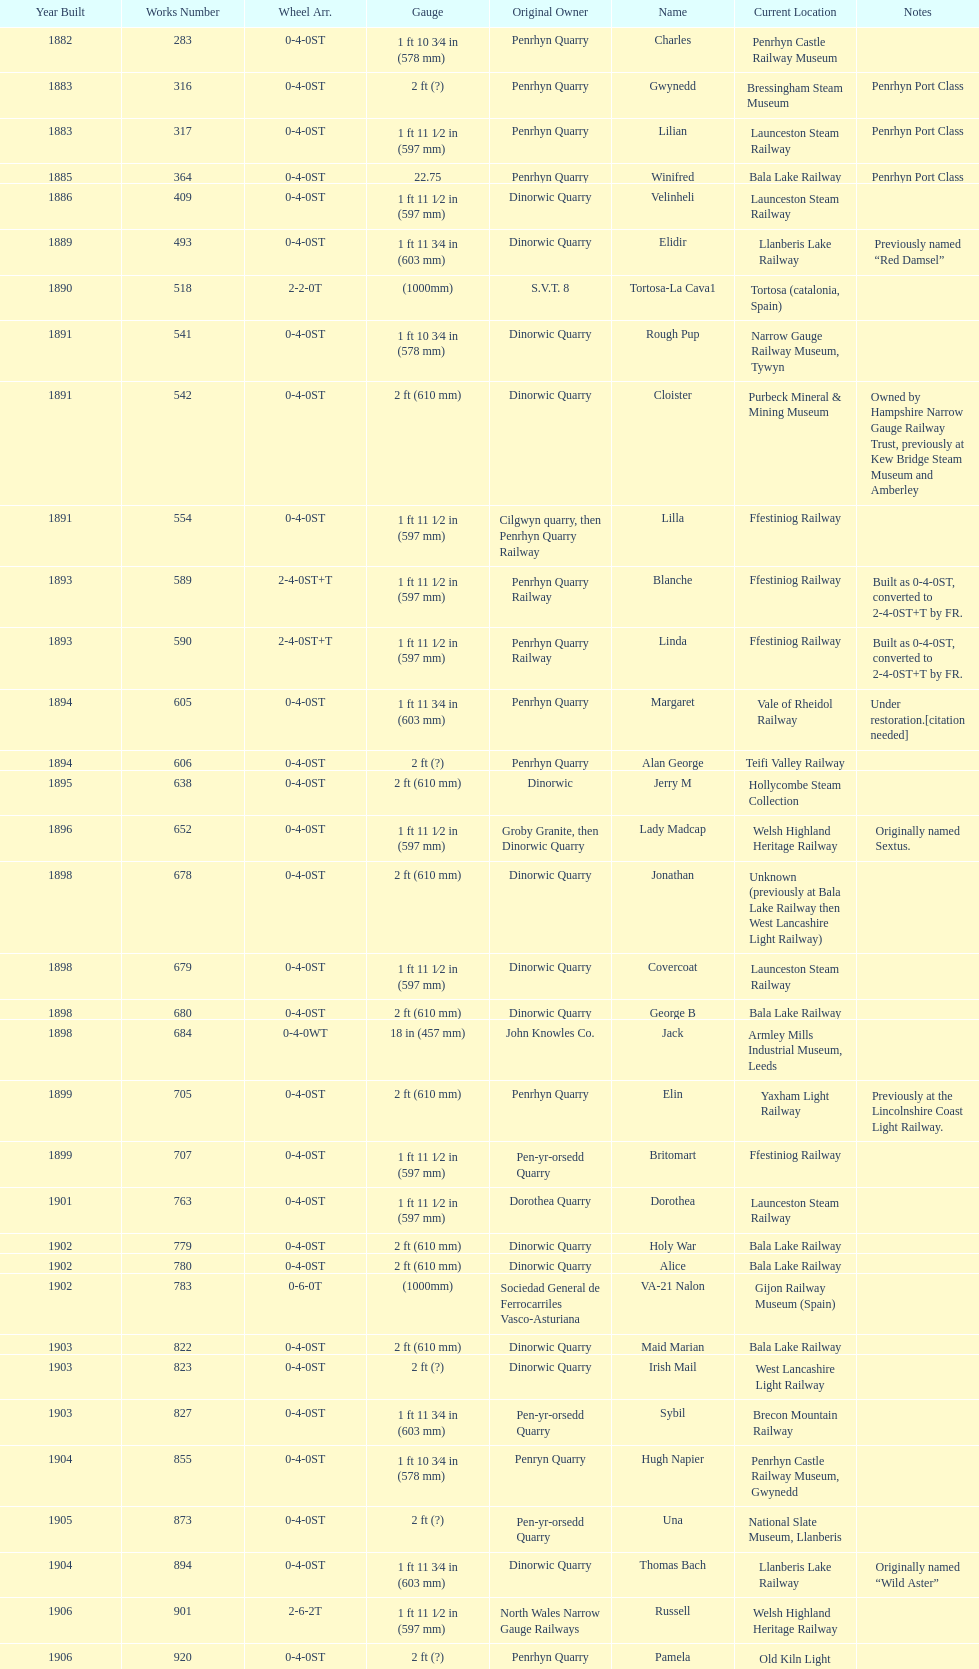Can you parse all the data within this table? {'header': ['Year Built', 'Works Number', 'Wheel Arr.', 'Gauge', 'Original Owner', 'Name', 'Current Location', 'Notes'], 'rows': [['1882', '283', '0-4-0ST', '1\xa0ft 10\xa03⁄4\xa0in (578\xa0mm)', 'Penrhyn Quarry', 'Charles', 'Penrhyn Castle Railway Museum', ''], ['1883', '316', '0-4-0ST', '2\xa0ft (?)', 'Penrhyn Quarry', 'Gwynedd', 'Bressingham Steam Museum', 'Penrhyn Port Class'], ['1883', '317', '0-4-0ST', '1\xa0ft 11\xa01⁄2\xa0in (597\xa0mm)', 'Penrhyn Quarry', 'Lilian', 'Launceston Steam Railway', 'Penrhyn Port Class'], ['1885', '364', '0-4-0ST', '22.75', 'Penrhyn Quarry', 'Winifred', 'Bala Lake Railway', 'Penrhyn Port Class'], ['1886', '409', '0-4-0ST', '1\xa0ft 11\xa01⁄2\xa0in (597\xa0mm)', 'Dinorwic Quarry', 'Velinheli', 'Launceston Steam Railway', ''], ['1889', '493', '0-4-0ST', '1\xa0ft 11\xa03⁄4\xa0in (603\xa0mm)', 'Dinorwic Quarry', 'Elidir', 'Llanberis Lake Railway', 'Previously named “Red Damsel”'], ['1890', '518', '2-2-0T', '(1000mm)', 'S.V.T. 8', 'Tortosa-La Cava1', 'Tortosa (catalonia, Spain)', ''], ['1891', '541', '0-4-0ST', '1\xa0ft 10\xa03⁄4\xa0in (578\xa0mm)', 'Dinorwic Quarry', 'Rough Pup', 'Narrow Gauge Railway Museum, Tywyn', ''], ['1891', '542', '0-4-0ST', '2\xa0ft (610\xa0mm)', 'Dinorwic Quarry', 'Cloister', 'Purbeck Mineral & Mining Museum', 'Owned by Hampshire Narrow Gauge Railway Trust, previously at Kew Bridge Steam Museum and Amberley'], ['1891', '554', '0-4-0ST', '1\xa0ft 11\xa01⁄2\xa0in (597\xa0mm)', 'Cilgwyn quarry, then Penrhyn Quarry Railway', 'Lilla', 'Ffestiniog Railway', ''], ['1893', '589', '2-4-0ST+T', '1\xa0ft 11\xa01⁄2\xa0in (597\xa0mm)', 'Penrhyn Quarry Railway', 'Blanche', 'Ffestiniog Railway', 'Built as 0-4-0ST, converted to 2-4-0ST+T by FR.'], ['1893', '590', '2-4-0ST+T', '1\xa0ft 11\xa01⁄2\xa0in (597\xa0mm)', 'Penrhyn Quarry Railway', 'Linda', 'Ffestiniog Railway', 'Built as 0-4-0ST, converted to 2-4-0ST+T by FR.'], ['1894', '605', '0-4-0ST', '1\xa0ft 11\xa03⁄4\xa0in (603\xa0mm)', 'Penrhyn Quarry', 'Margaret', 'Vale of Rheidol Railway', 'Under restoration.[citation needed]'], ['1894', '606', '0-4-0ST', '2\xa0ft (?)', 'Penrhyn Quarry', 'Alan George', 'Teifi Valley Railway', ''], ['1895', '638', '0-4-0ST', '2\xa0ft (610\xa0mm)', 'Dinorwic', 'Jerry M', 'Hollycombe Steam Collection', ''], ['1896', '652', '0-4-0ST', '1\xa0ft 11\xa01⁄2\xa0in (597\xa0mm)', 'Groby Granite, then Dinorwic Quarry', 'Lady Madcap', 'Welsh Highland Heritage Railway', 'Originally named Sextus.'], ['1898', '678', '0-4-0ST', '2\xa0ft (610\xa0mm)', 'Dinorwic Quarry', 'Jonathan', 'Unknown (previously at Bala Lake Railway then West Lancashire Light Railway)', ''], ['1898', '679', '0-4-0ST', '1\xa0ft 11\xa01⁄2\xa0in (597\xa0mm)', 'Dinorwic Quarry', 'Covercoat', 'Launceston Steam Railway', ''], ['1898', '680', '0-4-0ST', '2\xa0ft (610\xa0mm)', 'Dinorwic Quarry', 'George B', 'Bala Lake Railway', ''], ['1898', '684', '0-4-0WT', '18\xa0in (457\xa0mm)', 'John Knowles Co.', 'Jack', 'Armley Mills Industrial Museum, Leeds', ''], ['1899', '705', '0-4-0ST', '2\xa0ft (610\xa0mm)', 'Penrhyn Quarry', 'Elin', 'Yaxham Light Railway', 'Previously at the Lincolnshire Coast Light Railway.'], ['1899', '707', '0-4-0ST', '1\xa0ft 11\xa01⁄2\xa0in (597\xa0mm)', 'Pen-yr-orsedd Quarry', 'Britomart', 'Ffestiniog Railway', ''], ['1901', '763', '0-4-0ST', '1\xa0ft 11\xa01⁄2\xa0in (597\xa0mm)', 'Dorothea Quarry', 'Dorothea', 'Launceston Steam Railway', ''], ['1902', '779', '0-4-0ST', '2\xa0ft (610\xa0mm)', 'Dinorwic Quarry', 'Holy War', 'Bala Lake Railway', ''], ['1902', '780', '0-4-0ST', '2\xa0ft (610\xa0mm)', 'Dinorwic Quarry', 'Alice', 'Bala Lake Railway', ''], ['1902', '783', '0-6-0T', '(1000mm)', 'Sociedad General de Ferrocarriles Vasco-Asturiana', 'VA-21 Nalon', 'Gijon Railway Museum (Spain)', ''], ['1903', '822', '0-4-0ST', '2\xa0ft (610\xa0mm)', 'Dinorwic Quarry', 'Maid Marian', 'Bala Lake Railway', ''], ['1903', '823', '0-4-0ST', '2\xa0ft (?)', 'Dinorwic Quarry', 'Irish Mail', 'West Lancashire Light Railway', ''], ['1903', '827', '0-4-0ST', '1\xa0ft 11\xa03⁄4\xa0in (603\xa0mm)', 'Pen-yr-orsedd Quarry', 'Sybil', 'Brecon Mountain Railway', ''], ['1904', '855', '0-4-0ST', '1\xa0ft 10\xa03⁄4\xa0in (578\xa0mm)', 'Penryn Quarry', 'Hugh Napier', 'Penrhyn Castle Railway Museum, Gwynedd', ''], ['1905', '873', '0-4-0ST', '2\xa0ft (?)', 'Pen-yr-orsedd Quarry', 'Una', 'National Slate Museum, Llanberis', ''], ['1904', '894', '0-4-0ST', '1\xa0ft 11\xa03⁄4\xa0in (603\xa0mm)', 'Dinorwic Quarry', 'Thomas Bach', 'Llanberis Lake Railway', 'Originally named “Wild Aster”'], ['1906', '901', '2-6-2T', '1\xa0ft 11\xa01⁄2\xa0in (597\xa0mm)', 'North Wales Narrow Gauge Railways', 'Russell', 'Welsh Highland Heritage Railway', ''], ['1906', '920', '0-4-0ST', '2\xa0ft (?)', 'Penrhyn Quarry', 'Pamela', 'Old Kiln Light Railway', ''], ['1909', '994', '0-4-0ST', '2\xa0ft (?)', 'Penrhyn Quarry', 'Bill Harvey', 'Bressingham Steam Museum', 'previously George Sholto'], ['1918', '1312', '4-6-0T', '1\xa0ft\xa011\xa01⁄2\xa0in (597\xa0mm)', 'British War Department\\nEFOP #203', '---', 'Pampas Safari, Gravataí, RS, Brazil', '[citation needed]'], ['1918\\nor\\n1921?', '1313', '0-6-2T', '3\xa0ft\xa03\xa03⁄8\xa0in (1,000\xa0mm)', 'British War Department\\nUsina Leão Utinga #1\\nUsina Laginha #1', '---', 'Usina Laginha, União dos Palmares, AL, Brazil', '[citation needed]'], ['1920', '1404', '0-4-0WT', '18\xa0in (457\xa0mm)', 'John Knowles Co.', 'Gwen', 'Richard Farmer current owner, Northridge, California, USA', ''], ['1922', '1429', '0-4-0ST', '2\xa0ft (610\xa0mm)', 'Dinorwic', 'Lady Joan', 'Bredgar and Wormshill Light Railway', ''], ['1922', '1430', '0-4-0ST', '1\xa0ft 11\xa03⁄4\xa0in (603\xa0mm)', 'Dinorwic Quarry', 'Dolbadarn', 'Llanberis Lake Railway', ''], ['1937', '1859', '0-4-2T', '2\xa0ft (?)', 'Umtwalumi Valley Estate, Natal', '16 Carlisle', 'South Tynedale Railway', ''], ['1940', '2075', '0-4-2T', '2\xa0ft (?)', 'Chaka’s Kraal Sugar Estates, Natal', 'Chaka’s Kraal No. 6', 'North Gloucestershire Railway', ''], ['1954', '3815', '2-6-2T', '2\xa0ft 6\xa0in (762\xa0mm)', 'Sierra Leone Government Railway', '14', 'Welshpool and Llanfair Light Railway', ''], ['1971', '3902', '0-4-2ST', '2\xa0ft (610\xa0mm)', 'Trangkil Sugar Mill, Indonesia', 'Trangkil No.4', 'Statfold Barn Railway', 'Converted from 750\xa0mm (2\xa0ft\xa05\xa01⁄2\xa0in) gauge. Last steam locomotive to be built by Hunslet, and the last industrial steam locomotive built in Britain.']]} How many steam trains are currently positioned at the bala lake railway? 364. 